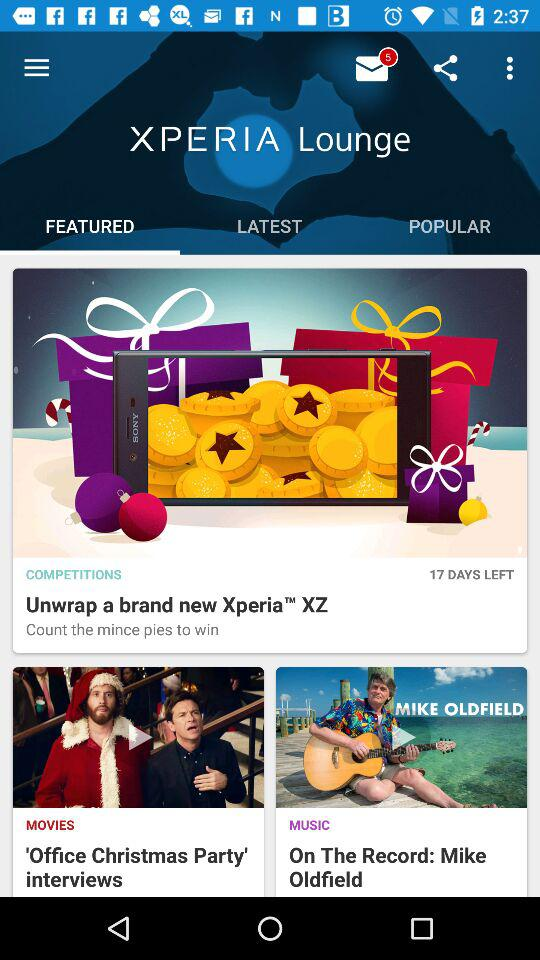How many days are left in the competitions? The number of days left in the competitions is 17. 